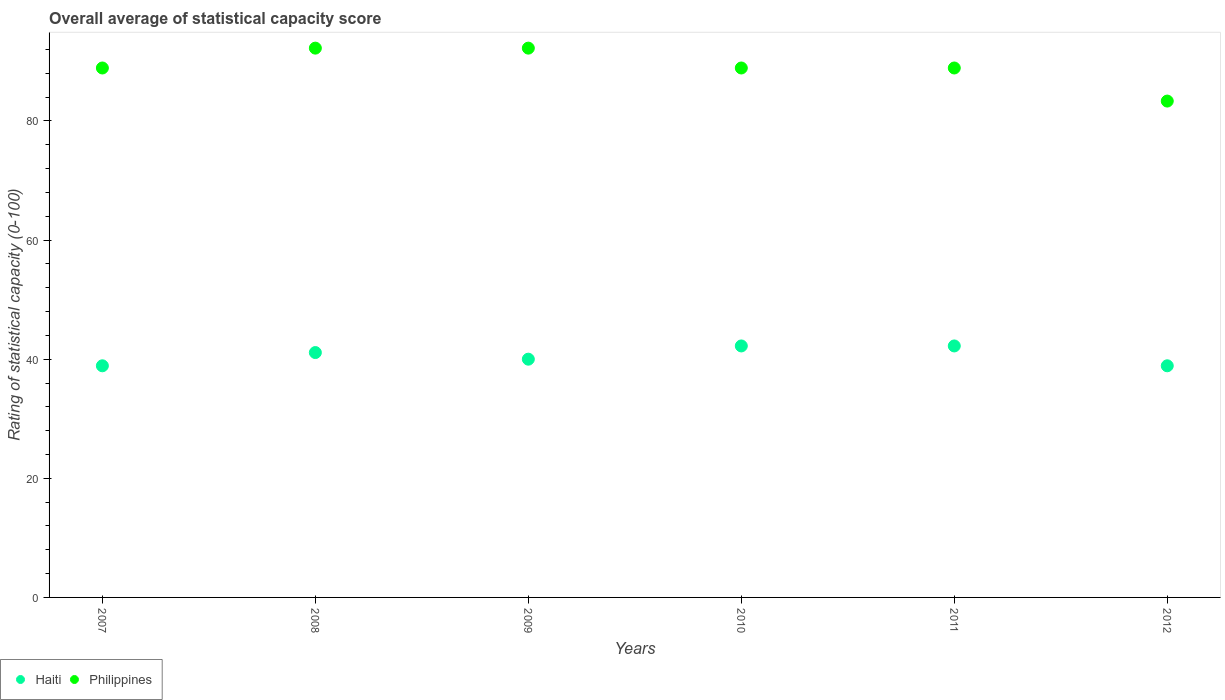How many different coloured dotlines are there?
Provide a succinct answer. 2. Is the number of dotlines equal to the number of legend labels?
Offer a terse response. Yes. What is the rating of statistical capacity in Haiti in 2007?
Offer a very short reply. 38.89. Across all years, what is the maximum rating of statistical capacity in Haiti?
Provide a succinct answer. 42.22. Across all years, what is the minimum rating of statistical capacity in Haiti?
Ensure brevity in your answer.  38.89. In which year was the rating of statistical capacity in Philippines minimum?
Offer a very short reply. 2012. What is the total rating of statistical capacity in Philippines in the graph?
Keep it short and to the point. 534.44. What is the difference between the rating of statistical capacity in Philippines in 2010 and that in 2012?
Offer a very short reply. 5.56. What is the difference between the rating of statistical capacity in Philippines in 2010 and the rating of statistical capacity in Haiti in 2009?
Ensure brevity in your answer.  48.89. What is the average rating of statistical capacity in Philippines per year?
Your answer should be compact. 89.07. In the year 2009, what is the difference between the rating of statistical capacity in Philippines and rating of statistical capacity in Haiti?
Your answer should be very brief. 52.22. In how many years, is the rating of statistical capacity in Haiti greater than 64?
Keep it short and to the point. 0. What is the ratio of the rating of statistical capacity in Haiti in 2007 to that in 2009?
Provide a short and direct response. 0.97. Is the rating of statistical capacity in Philippines in 2011 less than that in 2012?
Make the answer very short. No. Is the difference between the rating of statistical capacity in Philippines in 2010 and 2011 greater than the difference between the rating of statistical capacity in Haiti in 2010 and 2011?
Keep it short and to the point. No. What is the difference between the highest and the second highest rating of statistical capacity in Philippines?
Give a very brief answer. 0. What is the difference between the highest and the lowest rating of statistical capacity in Haiti?
Provide a short and direct response. 3.33. In how many years, is the rating of statistical capacity in Philippines greater than the average rating of statistical capacity in Philippines taken over all years?
Give a very brief answer. 2. Is the sum of the rating of statistical capacity in Philippines in 2010 and 2011 greater than the maximum rating of statistical capacity in Haiti across all years?
Make the answer very short. Yes. Does the rating of statistical capacity in Philippines monotonically increase over the years?
Offer a very short reply. No. Is the rating of statistical capacity in Philippines strictly greater than the rating of statistical capacity in Haiti over the years?
Your answer should be very brief. Yes. Is the rating of statistical capacity in Haiti strictly less than the rating of statistical capacity in Philippines over the years?
Offer a terse response. Yes. What is the difference between two consecutive major ticks on the Y-axis?
Give a very brief answer. 20. Does the graph contain grids?
Offer a terse response. No. How are the legend labels stacked?
Give a very brief answer. Horizontal. What is the title of the graph?
Your response must be concise. Overall average of statistical capacity score. What is the label or title of the Y-axis?
Keep it short and to the point. Rating of statistical capacity (0-100). What is the Rating of statistical capacity (0-100) in Haiti in 2007?
Offer a very short reply. 38.89. What is the Rating of statistical capacity (0-100) of Philippines in 2007?
Provide a succinct answer. 88.89. What is the Rating of statistical capacity (0-100) in Haiti in 2008?
Offer a very short reply. 41.11. What is the Rating of statistical capacity (0-100) in Philippines in 2008?
Your answer should be very brief. 92.22. What is the Rating of statistical capacity (0-100) of Philippines in 2009?
Offer a very short reply. 92.22. What is the Rating of statistical capacity (0-100) in Haiti in 2010?
Your answer should be compact. 42.22. What is the Rating of statistical capacity (0-100) of Philippines in 2010?
Your answer should be very brief. 88.89. What is the Rating of statistical capacity (0-100) of Haiti in 2011?
Provide a succinct answer. 42.22. What is the Rating of statistical capacity (0-100) in Philippines in 2011?
Your answer should be compact. 88.89. What is the Rating of statistical capacity (0-100) in Haiti in 2012?
Provide a short and direct response. 38.89. What is the Rating of statistical capacity (0-100) of Philippines in 2012?
Ensure brevity in your answer.  83.33. Across all years, what is the maximum Rating of statistical capacity (0-100) in Haiti?
Your answer should be compact. 42.22. Across all years, what is the maximum Rating of statistical capacity (0-100) of Philippines?
Your response must be concise. 92.22. Across all years, what is the minimum Rating of statistical capacity (0-100) in Haiti?
Your answer should be very brief. 38.89. Across all years, what is the minimum Rating of statistical capacity (0-100) of Philippines?
Your answer should be very brief. 83.33. What is the total Rating of statistical capacity (0-100) of Haiti in the graph?
Your answer should be very brief. 243.33. What is the total Rating of statistical capacity (0-100) of Philippines in the graph?
Your response must be concise. 534.44. What is the difference between the Rating of statistical capacity (0-100) in Haiti in 2007 and that in 2008?
Offer a terse response. -2.22. What is the difference between the Rating of statistical capacity (0-100) of Philippines in 2007 and that in 2008?
Give a very brief answer. -3.33. What is the difference between the Rating of statistical capacity (0-100) in Haiti in 2007 and that in 2009?
Make the answer very short. -1.11. What is the difference between the Rating of statistical capacity (0-100) in Haiti in 2007 and that in 2010?
Provide a succinct answer. -3.33. What is the difference between the Rating of statistical capacity (0-100) of Haiti in 2007 and that in 2012?
Your response must be concise. 0. What is the difference between the Rating of statistical capacity (0-100) in Philippines in 2007 and that in 2012?
Your response must be concise. 5.56. What is the difference between the Rating of statistical capacity (0-100) of Haiti in 2008 and that in 2009?
Your answer should be very brief. 1.11. What is the difference between the Rating of statistical capacity (0-100) of Haiti in 2008 and that in 2010?
Provide a succinct answer. -1.11. What is the difference between the Rating of statistical capacity (0-100) in Philippines in 2008 and that in 2010?
Keep it short and to the point. 3.33. What is the difference between the Rating of statistical capacity (0-100) in Haiti in 2008 and that in 2011?
Your answer should be compact. -1.11. What is the difference between the Rating of statistical capacity (0-100) of Philippines in 2008 and that in 2011?
Your answer should be compact. 3.33. What is the difference between the Rating of statistical capacity (0-100) in Haiti in 2008 and that in 2012?
Offer a terse response. 2.22. What is the difference between the Rating of statistical capacity (0-100) in Philippines in 2008 and that in 2012?
Keep it short and to the point. 8.89. What is the difference between the Rating of statistical capacity (0-100) in Haiti in 2009 and that in 2010?
Give a very brief answer. -2.22. What is the difference between the Rating of statistical capacity (0-100) in Philippines in 2009 and that in 2010?
Your answer should be compact. 3.33. What is the difference between the Rating of statistical capacity (0-100) in Haiti in 2009 and that in 2011?
Your response must be concise. -2.22. What is the difference between the Rating of statistical capacity (0-100) in Philippines in 2009 and that in 2011?
Ensure brevity in your answer.  3.33. What is the difference between the Rating of statistical capacity (0-100) of Philippines in 2009 and that in 2012?
Offer a very short reply. 8.89. What is the difference between the Rating of statistical capacity (0-100) in Haiti in 2010 and that in 2011?
Your answer should be very brief. 0. What is the difference between the Rating of statistical capacity (0-100) of Philippines in 2010 and that in 2011?
Your answer should be very brief. 0. What is the difference between the Rating of statistical capacity (0-100) in Philippines in 2010 and that in 2012?
Offer a very short reply. 5.56. What is the difference between the Rating of statistical capacity (0-100) of Haiti in 2011 and that in 2012?
Offer a terse response. 3.33. What is the difference between the Rating of statistical capacity (0-100) in Philippines in 2011 and that in 2012?
Provide a succinct answer. 5.56. What is the difference between the Rating of statistical capacity (0-100) of Haiti in 2007 and the Rating of statistical capacity (0-100) of Philippines in 2008?
Your answer should be very brief. -53.33. What is the difference between the Rating of statistical capacity (0-100) of Haiti in 2007 and the Rating of statistical capacity (0-100) of Philippines in 2009?
Your answer should be compact. -53.33. What is the difference between the Rating of statistical capacity (0-100) in Haiti in 2007 and the Rating of statistical capacity (0-100) in Philippines in 2010?
Your answer should be very brief. -50. What is the difference between the Rating of statistical capacity (0-100) in Haiti in 2007 and the Rating of statistical capacity (0-100) in Philippines in 2012?
Provide a succinct answer. -44.44. What is the difference between the Rating of statistical capacity (0-100) in Haiti in 2008 and the Rating of statistical capacity (0-100) in Philippines in 2009?
Offer a very short reply. -51.11. What is the difference between the Rating of statistical capacity (0-100) in Haiti in 2008 and the Rating of statistical capacity (0-100) in Philippines in 2010?
Provide a succinct answer. -47.78. What is the difference between the Rating of statistical capacity (0-100) of Haiti in 2008 and the Rating of statistical capacity (0-100) of Philippines in 2011?
Give a very brief answer. -47.78. What is the difference between the Rating of statistical capacity (0-100) of Haiti in 2008 and the Rating of statistical capacity (0-100) of Philippines in 2012?
Provide a succinct answer. -42.22. What is the difference between the Rating of statistical capacity (0-100) in Haiti in 2009 and the Rating of statistical capacity (0-100) in Philippines in 2010?
Offer a terse response. -48.89. What is the difference between the Rating of statistical capacity (0-100) in Haiti in 2009 and the Rating of statistical capacity (0-100) in Philippines in 2011?
Offer a very short reply. -48.89. What is the difference between the Rating of statistical capacity (0-100) in Haiti in 2009 and the Rating of statistical capacity (0-100) in Philippines in 2012?
Ensure brevity in your answer.  -43.33. What is the difference between the Rating of statistical capacity (0-100) in Haiti in 2010 and the Rating of statistical capacity (0-100) in Philippines in 2011?
Your answer should be compact. -46.67. What is the difference between the Rating of statistical capacity (0-100) of Haiti in 2010 and the Rating of statistical capacity (0-100) of Philippines in 2012?
Your answer should be compact. -41.11. What is the difference between the Rating of statistical capacity (0-100) of Haiti in 2011 and the Rating of statistical capacity (0-100) of Philippines in 2012?
Offer a terse response. -41.11. What is the average Rating of statistical capacity (0-100) in Haiti per year?
Provide a succinct answer. 40.56. What is the average Rating of statistical capacity (0-100) in Philippines per year?
Your answer should be very brief. 89.07. In the year 2008, what is the difference between the Rating of statistical capacity (0-100) in Haiti and Rating of statistical capacity (0-100) in Philippines?
Your response must be concise. -51.11. In the year 2009, what is the difference between the Rating of statistical capacity (0-100) in Haiti and Rating of statistical capacity (0-100) in Philippines?
Your answer should be very brief. -52.22. In the year 2010, what is the difference between the Rating of statistical capacity (0-100) of Haiti and Rating of statistical capacity (0-100) of Philippines?
Your answer should be very brief. -46.67. In the year 2011, what is the difference between the Rating of statistical capacity (0-100) of Haiti and Rating of statistical capacity (0-100) of Philippines?
Give a very brief answer. -46.67. In the year 2012, what is the difference between the Rating of statistical capacity (0-100) in Haiti and Rating of statistical capacity (0-100) in Philippines?
Your response must be concise. -44.44. What is the ratio of the Rating of statistical capacity (0-100) in Haiti in 2007 to that in 2008?
Provide a short and direct response. 0.95. What is the ratio of the Rating of statistical capacity (0-100) in Philippines in 2007 to that in 2008?
Give a very brief answer. 0.96. What is the ratio of the Rating of statistical capacity (0-100) of Haiti in 2007 to that in 2009?
Ensure brevity in your answer.  0.97. What is the ratio of the Rating of statistical capacity (0-100) in Philippines in 2007 to that in 2009?
Your answer should be very brief. 0.96. What is the ratio of the Rating of statistical capacity (0-100) in Haiti in 2007 to that in 2010?
Your answer should be very brief. 0.92. What is the ratio of the Rating of statistical capacity (0-100) in Haiti in 2007 to that in 2011?
Provide a short and direct response. 0.92. What is the ratio of the Rating of statistical capacity (0-100) of Philippines in 2007 to that in 2012?
Offer a terse response. 1.07. What is the ratio of the Rating of statistical capacity (0-100) in Haiti in 2008 to that in 2009?
Make the answer very short. 1.03. What is the ratio of the Rating of statistical capacity (0-100) in Haiti in 2008 to that in 2010?
Offer a terse response. 0.97. What is the ratio of the Rating of statistical capacity (0-100) of Philippines in 2008 to that in 2010?
Give a very brief answer. 1.04. What is the ratio of the Rating of statistical capacity (0-100) of Haiti in 2008 to that in 2011?
Give a very brief answer. 0.97. What is the ratio of the Rating of statistical capacity (0-100) in Philippines in 2008 to that in 2011?
Provide a short and direct response. 1.04. What is the ratio of the Rating of statistical capacity (0-100) of Haiti in 2008 to that in 2012?
Your answer should be very brief. 1.06. What is the ratio of the Rating of statistical capacity (0-100) in Philippines in 2008 to that in 2012?
Give a very brief answer. 1.11. What is the ratio of the Rating of statistical capacity (0-100) in Philippines in 2009 to that in 2010?
Your response must be concise. 1.04. What is the ratio of the Rating of statistical capacity (0-100) of Philippines in 2009 to that in 2011?
Provide a short and direct response. 1.04. What is the ratio of the Rating of statistical capacity (0-100) of Haiti in 2009 to that in 2012?
Your answer should be compact. 1.03. What is the ratio of the Rating of statistical capacity (0-100) of Philippines in 2009 to that in 2012?
Provide a short and direct response. 1.11. What is the ratio of the Rating of statistical capacity (0-100) of Haiti in 2010 to that in 2011?
Offer a terse response. 1. What is the ratio of the Rating of statistical capacity (0-100) in Philippines in 2010 to that in 2011?
Your answer should be compact. 1. What is the ratio of the Rating of statistical capacity (0-100) of Haiti in 2010 to that in 2012?
Provide a succinct answer. 1.09. What is the ratio of the Rating of statistical capacity (0-100) of Philippines in 2010 to that in 2012?
Offer a terse response. 1.07. What is the ratio of the Rating of statistical capacity (0-100) in Haiti in 2011 to that in 2012?
Provide a succinct answer. 1.09. What is the ratio of the Rating of statistical capacity (0-100) of Philippines in 2011 to that in 2012?
Offer a terse response. 1.07. What is the difference between the highest and the second highest Rating of statistical capacity (0-100) in Haiti?
Your answer should be compact. 0. What is the difference between the highest and the second highest Rating of statistical capacity (0-100) in Philippines?
Give a very brief answer. 0. What is the difference between the highest and the lowest Rating of statistical capacity (0-100) of Philippines?
Ensure brevity in your answer.  8.89. 